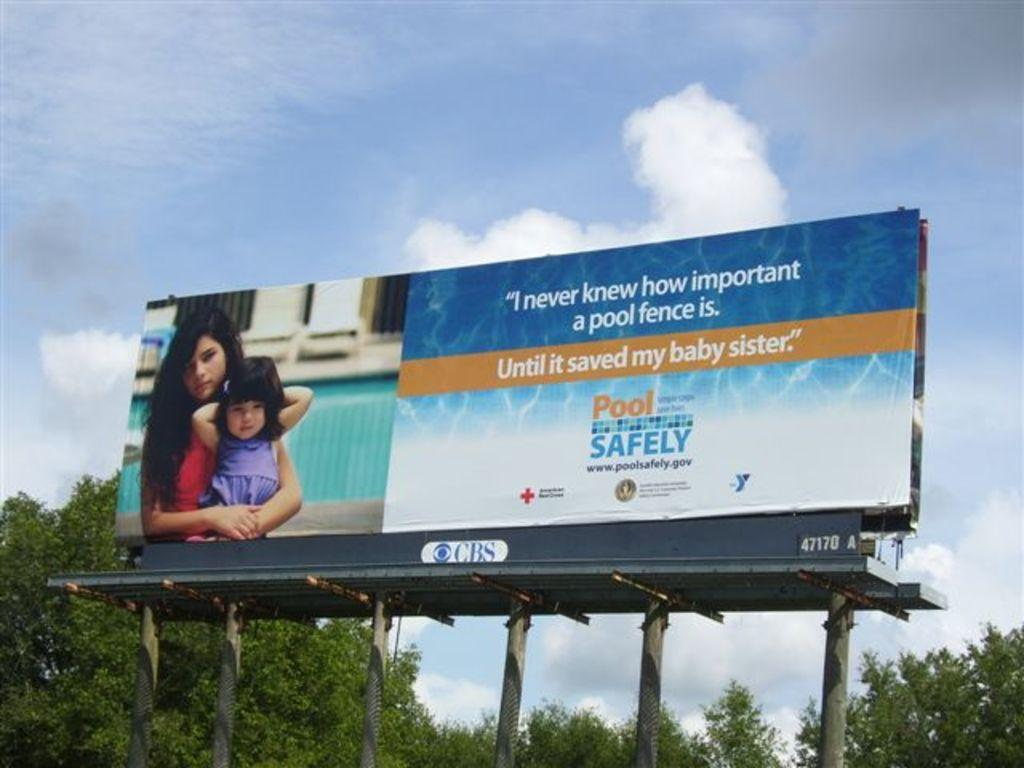<image>
Give a short and clear explanation of the subsequent image. A billboard shows the importance of pool safety. 